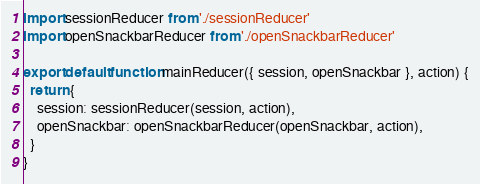<code> <loc_0><loc_0><loc_500><loc_500><_JavaScript_>import sessionReducer from './sessionReducer'
import openSnackbarReducer from './openSnackbarReducer'

export default function mainReducer({ session, openSnackbar }, action) {
  return {
    session: sessionReducer(session, action),
    openSnackbar: openSnackbarReducer(openSnackbar, action),
  }
}
</code> 